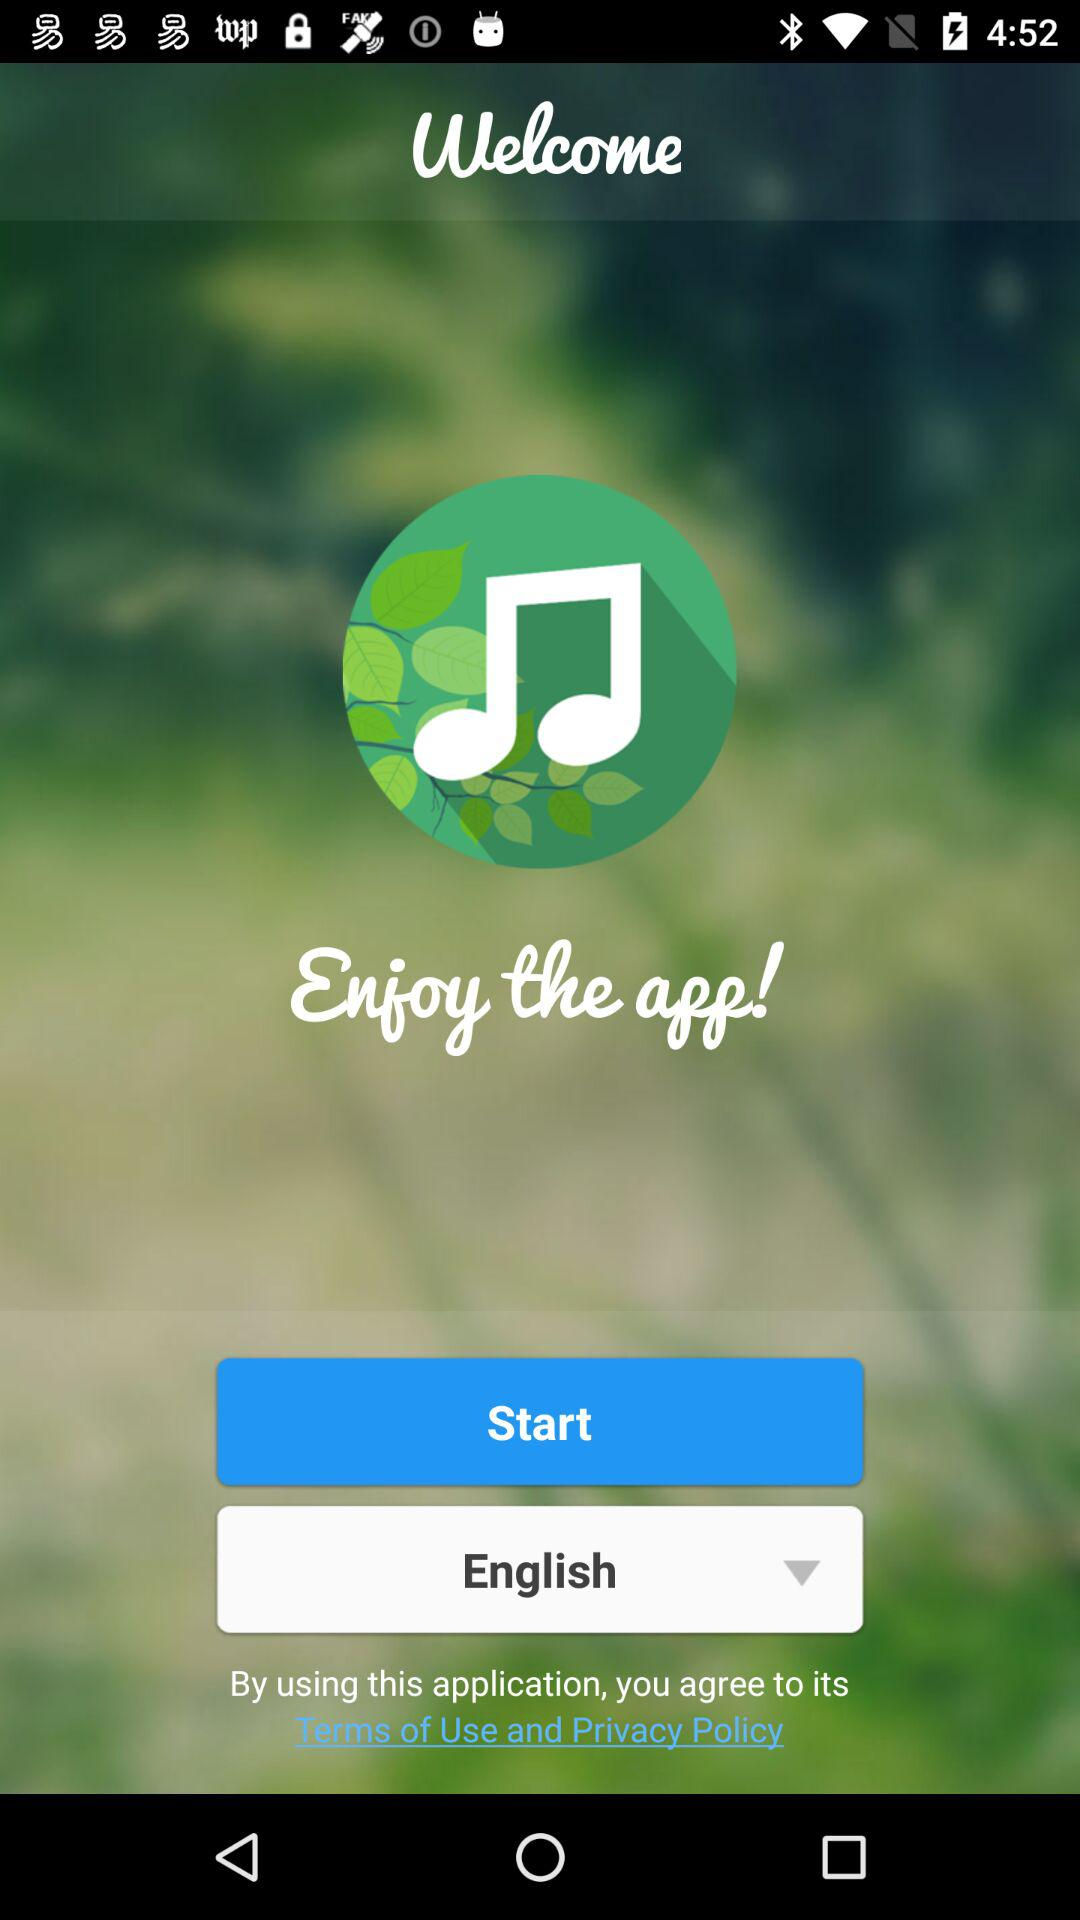What is the selected language? The selected language is English. 